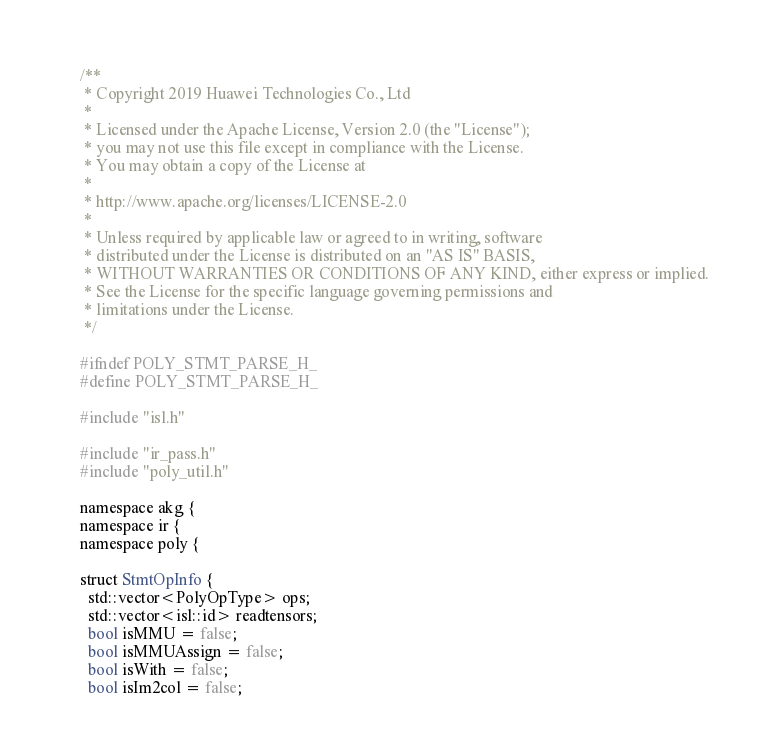Convert code to text. <code><loc_0><loc_0><loc_500><loc_500><_C_>/**
 * Copyright 2019 Huawei Technologies Co., Ltd
 *
 * Licensed under the Apache License, Version 2.0 (the "License");
 * you may not use this file except in compliance with the License.
 * You may obtain a copy of the License at
 *
 * http://www.apache.org/licenses/LICENSE-2.0
 *
 * Unless required by applicable law or agreed to in writing, software
 * distributed under the License is distributed on an "AS IS" BASIS,
 * WITHOUT WARRANTIES OR CONDITIONS OF ANY KIND, either express or implied.
 * See the License for the specific language governing permissions and
 * limitations under the License.
 */

#ifndef POLY_STMT_PARSE_H_
#define POLY_STMT_PARSE_H_

#include "isl.h"

#include "ir_pass.h"
#include "poly_util.h"

namespace akg {
namespace ir {
namespace poly {

struct StmtOpInfo {
  std::vector<PolyOpType> ops;
  std::vector<isl::id> readtensors;
  bool isMMU = false;
  bool isMMUAssign = false;
  bool isWith = false;
  bool isIm2col = false;</code> 